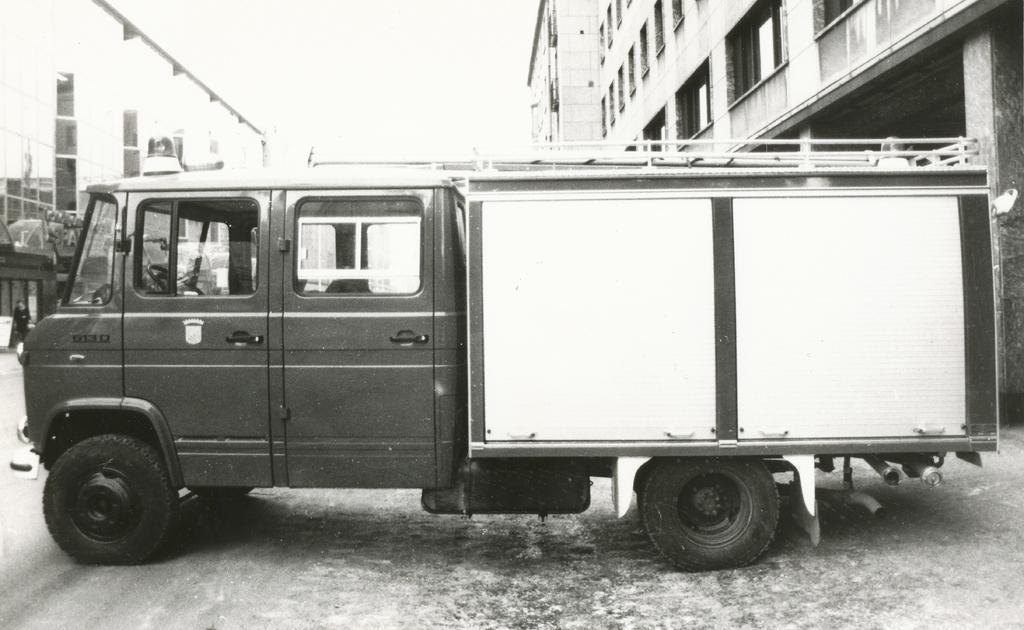Describe this image in one or two sentences. In the center of the image we can see a vehicle on the road. In the background there are buildings and sky. 